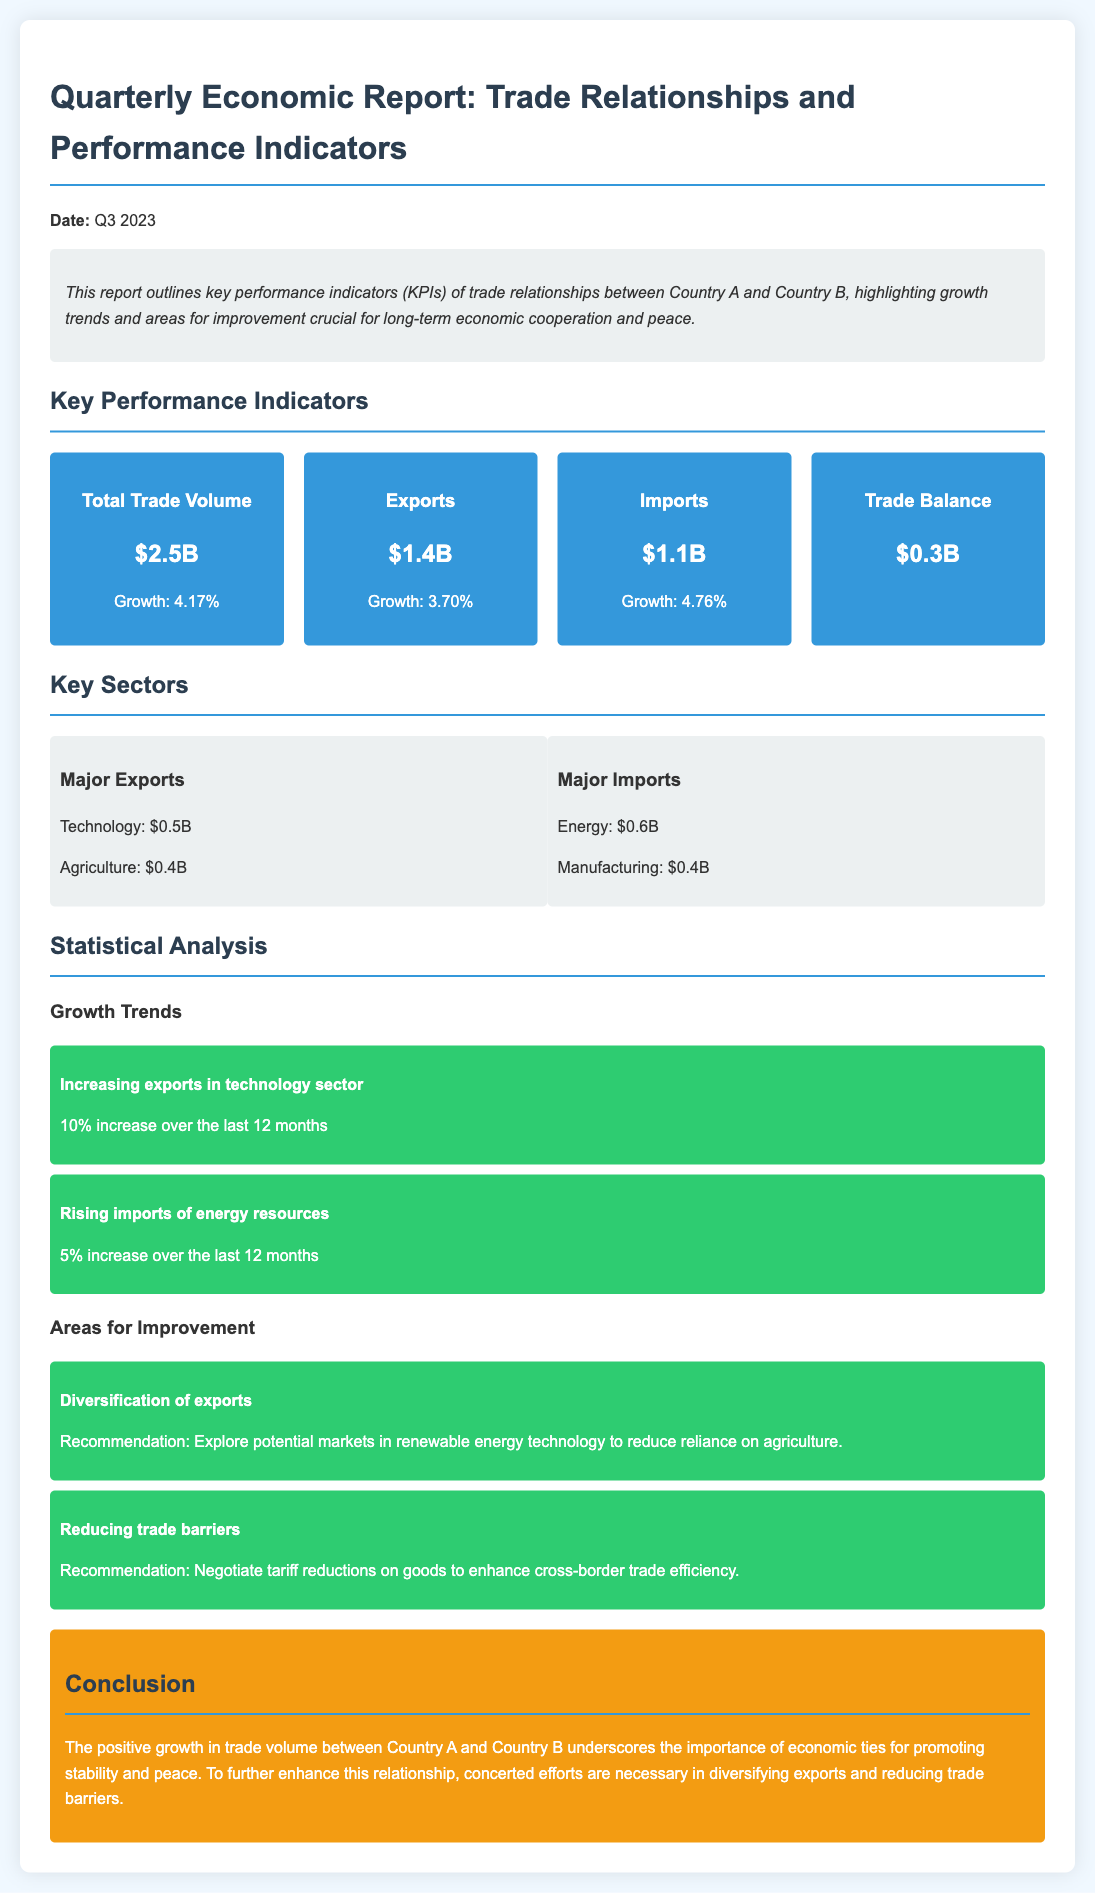what is the total trade volume? The total trade volume is provided as a key performance indicator in the document, which is $2.5B.
Answer: $2.5B what is the growth percentage of imports? The growth percentage of imports is listed under the KPIs, specified as 4.76%.
Answer: 4.76% how much did technology exports increase over the last 12 months? The document mentions a 10% increase in technology exports over the last 12 months.
Answer: 10% what are the major imports listed in the report? The major imports are specified in the key sectors section, which includes Energy and Manufacturing.
Answer: Energy, Manufacturing what is one recommendation for areas of improvement? The document provides a recommendation to explore potential markets in renewable energy technology for diversification of exports.
Answer: Explore potential markets in renewable energy technology 